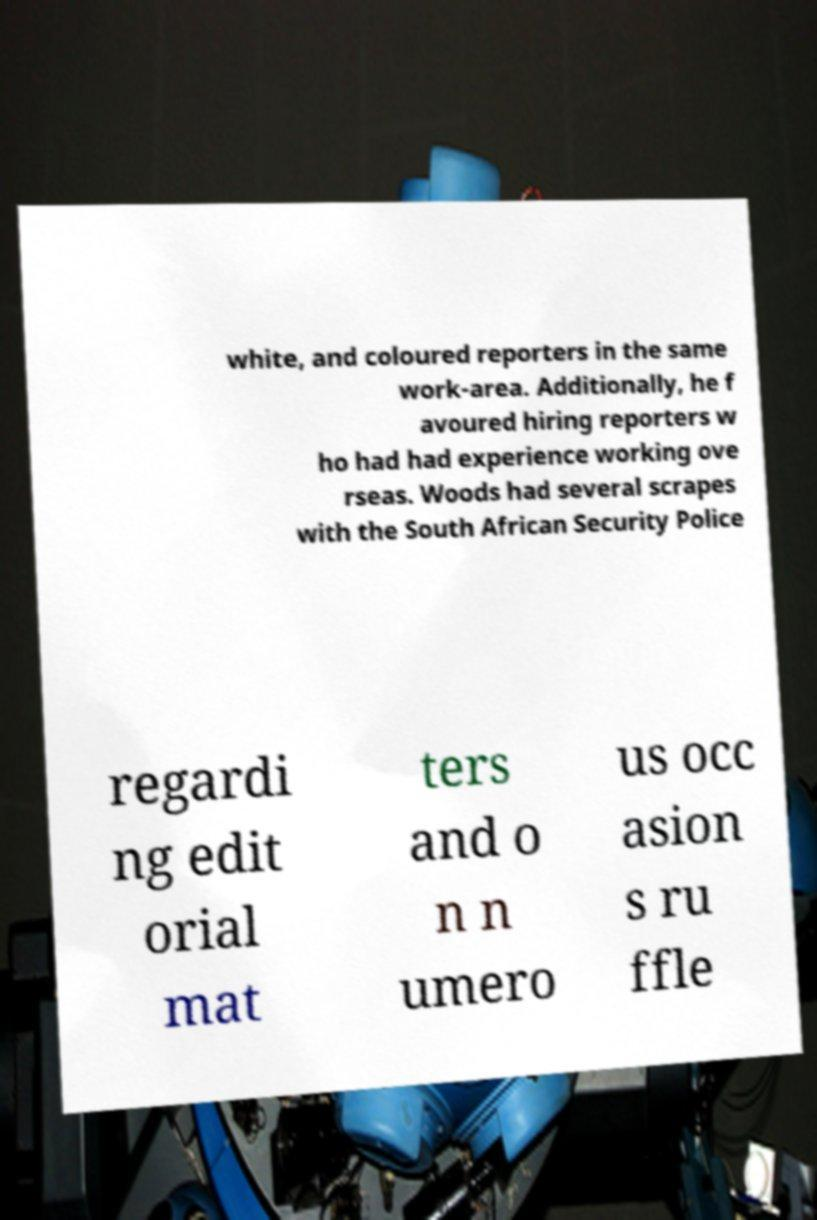Please identify and transcribe the text found in this image. white, and coloured reporters in the same work-area. Additionally, he f avoured hiring reporters w ho had had experience working ove rseas. Woods had several scrapes with the South African Security Police regardi ng edit orial mat ters and o n n umero us occ asion s ru ffle 